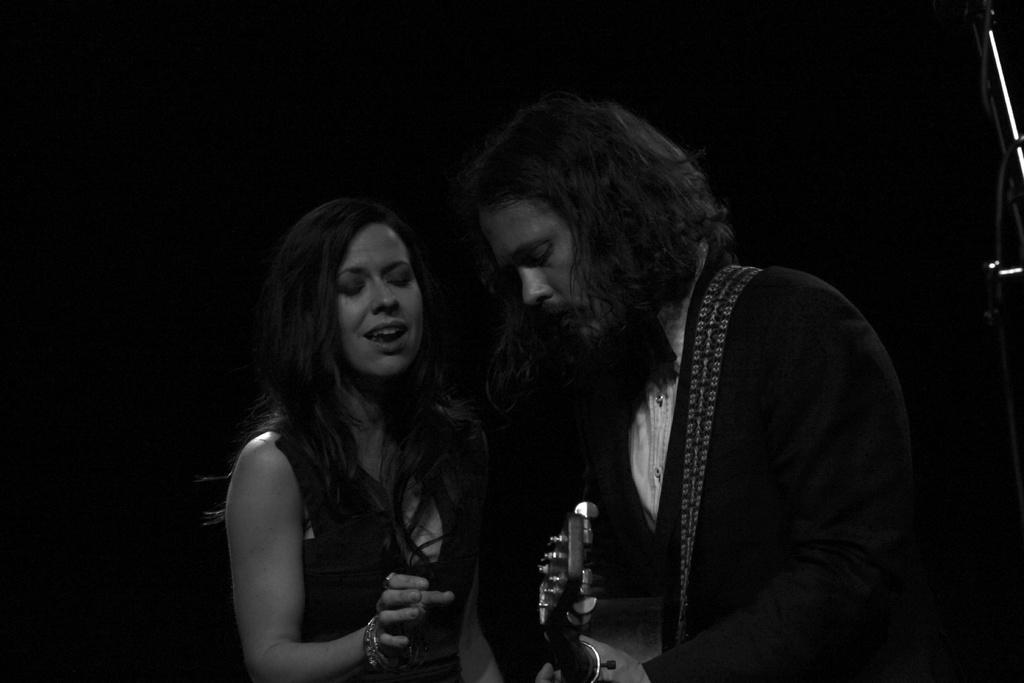How many people are in the image? There are two people in the image, a woman and a man. What is the man holding in the image? The man is holding an object. Can you describe the background of the image? The background of the image is dark. Where is the squirrel taking a bath in the image? There is no squirrel or bath present in the image. What type of building can be seen in the background of the image? There is no building visible in the image; the background is dark. 